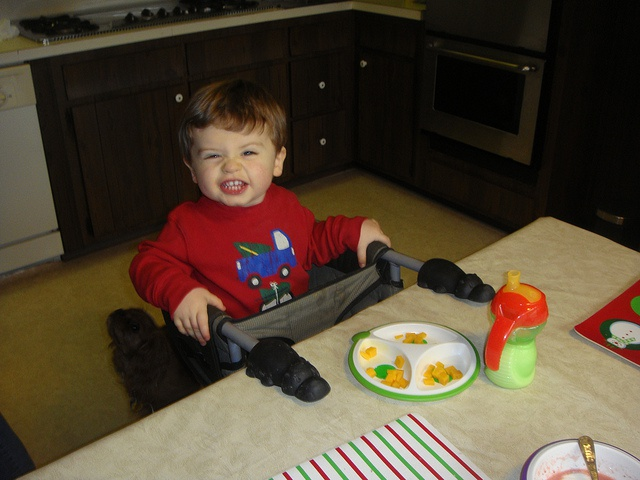Describe the objects in this image and their specific colors. I can see dining table in black and tan tones, people in black, maroon, and tan tones, chair in black and gray tones, oven in black, gray, and darkgreen tones, and cup in black, red, lightgreen, and olive tones in this image. 